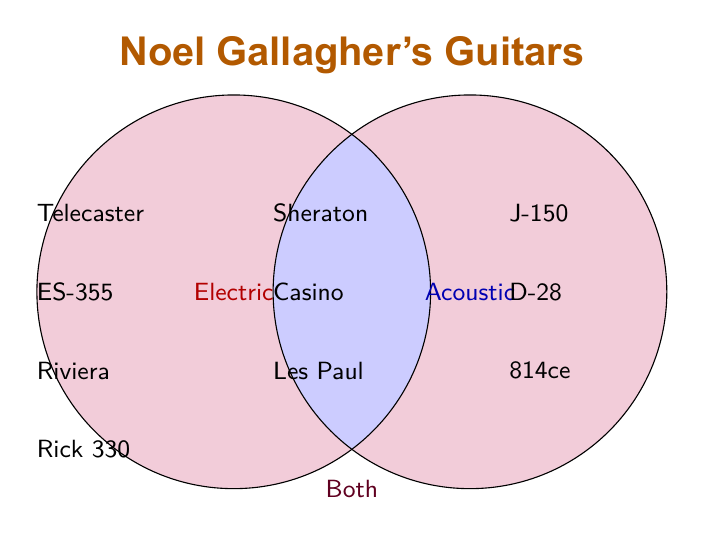What are the guitar types listed for both Electric and Acoustic categories? Look at the part of the Venn Diagram where the two circles overlap, representing guitars used in both categories.
Answer: Sheraton, Casino, Les Paul Which guitar brands does Noel Gallagher use for electric guitars? Identify the text inside the "Electric" circle that mentions brands.
Answer: Fender, Gibson, Epiphone, Rickenbacker How many unique acoustic guitar models are listed? Count the number of items specifically in the "Acoustic" circle.
Answer: 3 How many guitars are used only as electric but not as acoustic? Count the items inside the "Electric" circle excluding the overlap.
Answer: 4 Which guitars belong to the "Both" category? Find the items listed in the overlapping section of the two circles.
Answer: Sheraton, Casino, Les Paul Which category has more guitar models, Electric or Acoustic? Compare the number of items in the "Electric" and "Acoustic" circles.
Answer: Electric Name one guitar model that is only acoustic. Identify any item inside the "Acoustic" circle excluding the overlap.
Answer: J-150 Are there more electric guitars or guitars used in both categories? Compare the number of items in the "Electric" circle excluding overlap with the overlap section.
Answer: Electric List one guitar that does not belong to the "Both" category. Identify any guitar that is listed solely in either the "Electric" or "Acoustic" circle without overlap.
Answer: Telecaster 